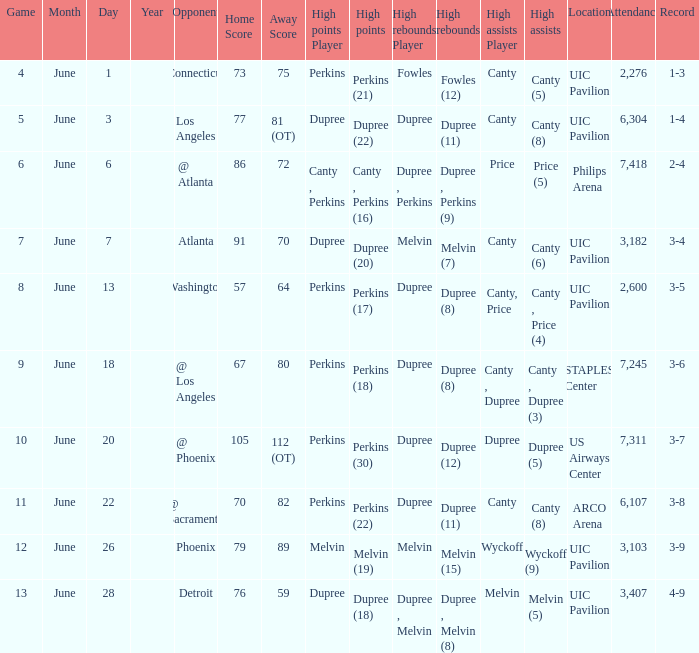Who had the most assists in the game that led to a 3-7 record? Dupree (5). 